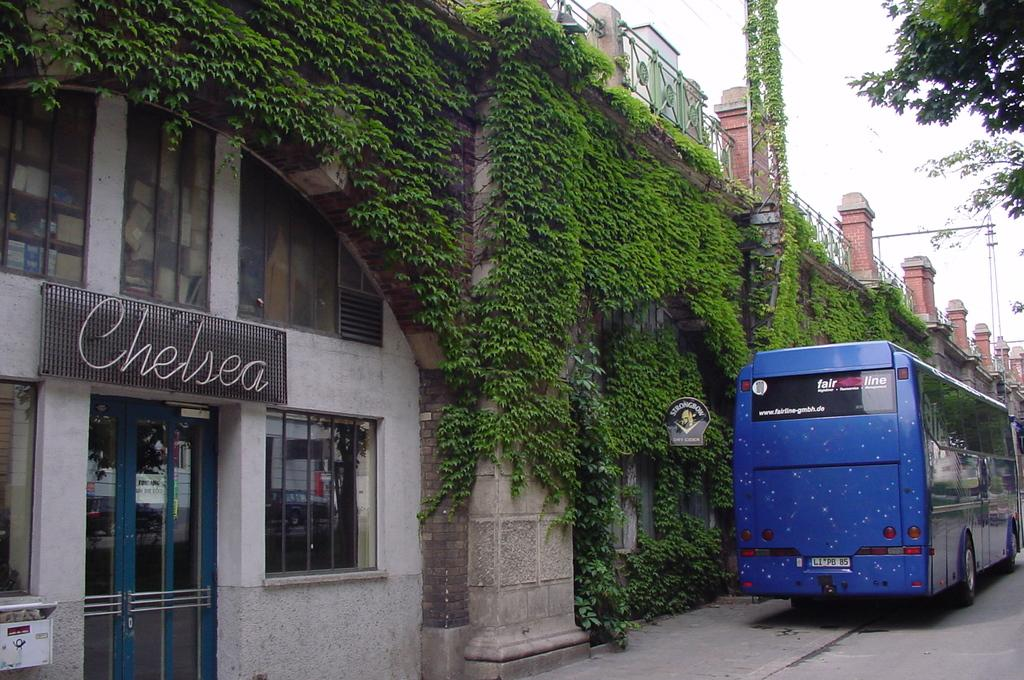What type of structures can be seen in the image? There are doors, windows, name boards, and a building visible in the image. What type of vegetation is present in the image? There are plants and trees in the image. What type of barrier can be seen in the image? There is a fence in the image. What mode of transportation can be seen in the image? There is a bus on the road in the image. What is visible in the background of the image? The sky is visible in the background of the image. Where is the faucet located in the image? There is no faucet present in the image. What type of rose can be seen growing among the plants in the image? There are no roses present in the image; only plants and trees are visible. 